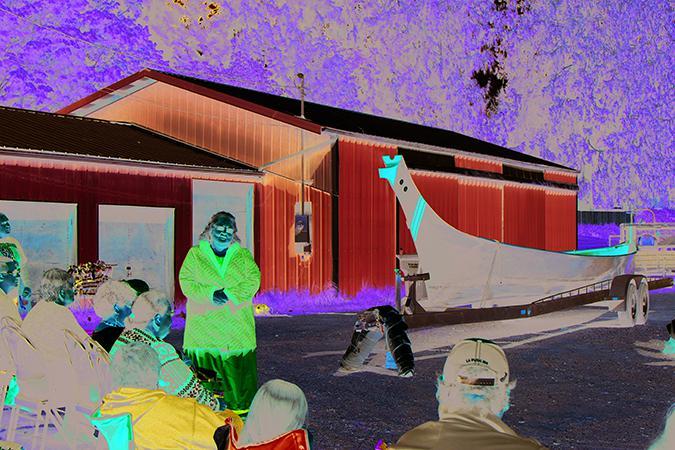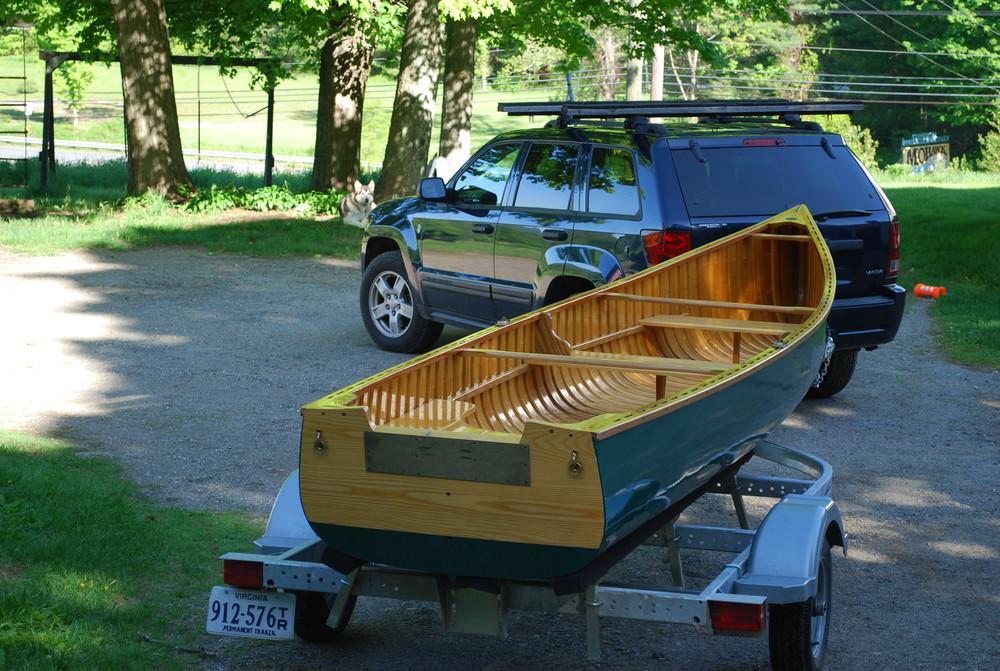The first image is the image on the left, the second image is the image on the right. Evaluate the accuracy of this statement regarding the images: "An image of a trailer includes two boats and a bicycle.". Is it true? Answer yes or no. No. 